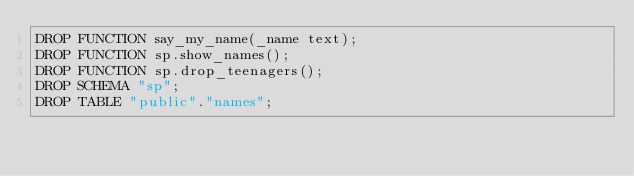<code> <loc_0><loc_0><loc_500><loc_500><_SQL_>DROP FUNCTION say_my_name(_name text);
DROP FUNCTION sp.show_names();
DROP FUNCTION sp.drop_teenagers();
DROP SCHEMA "sp";
DROP TABLE "public"."names";
</code> 